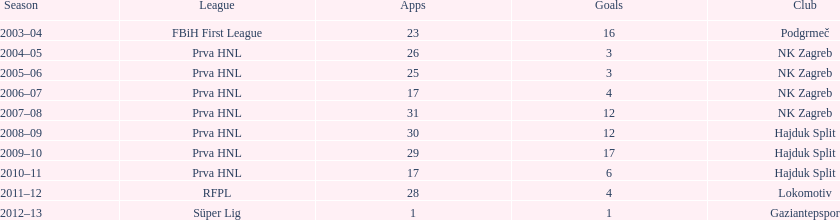Did ibricic score more or less goals in his 3 seasons with hajduk split when compared to his 4 seasons with nk zagreb? More. 